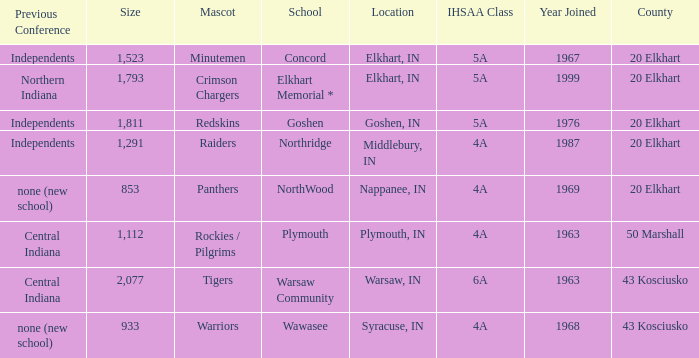What is the IHSAA class for the team located in Middlebury, IN? 4A. 